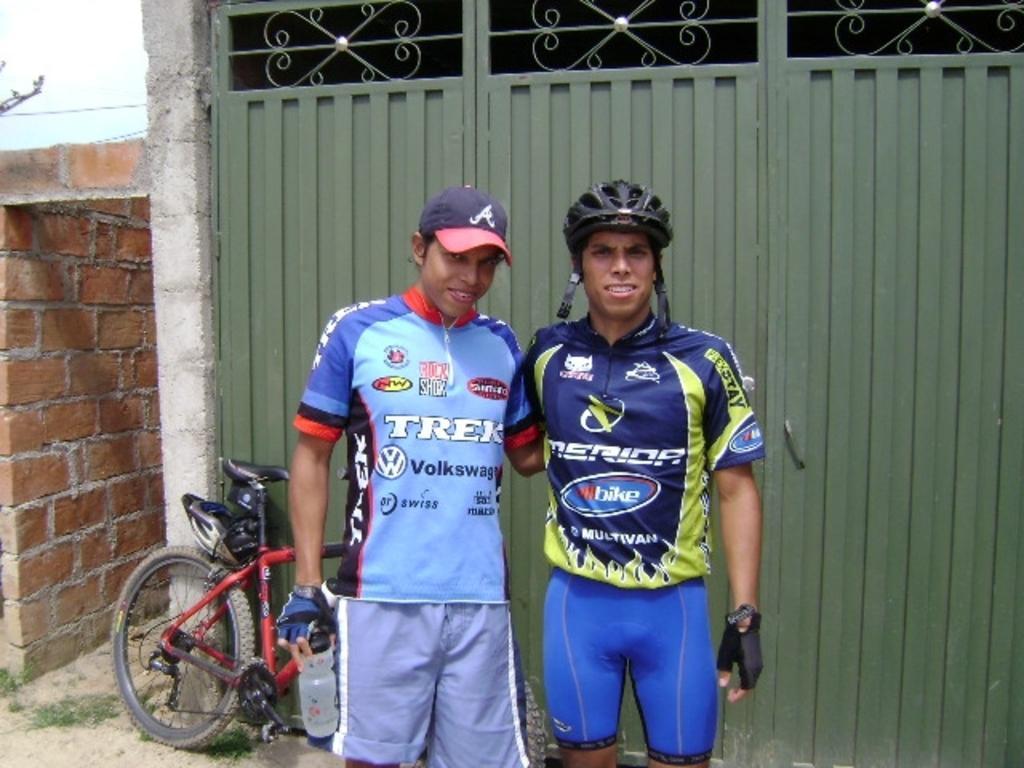In one or two sentences, can you explain what this image depicts? In the foreground we can see two men standing. In the middle there are gate, bicycle and a brick wall. At the top left corner it looks like sky. 